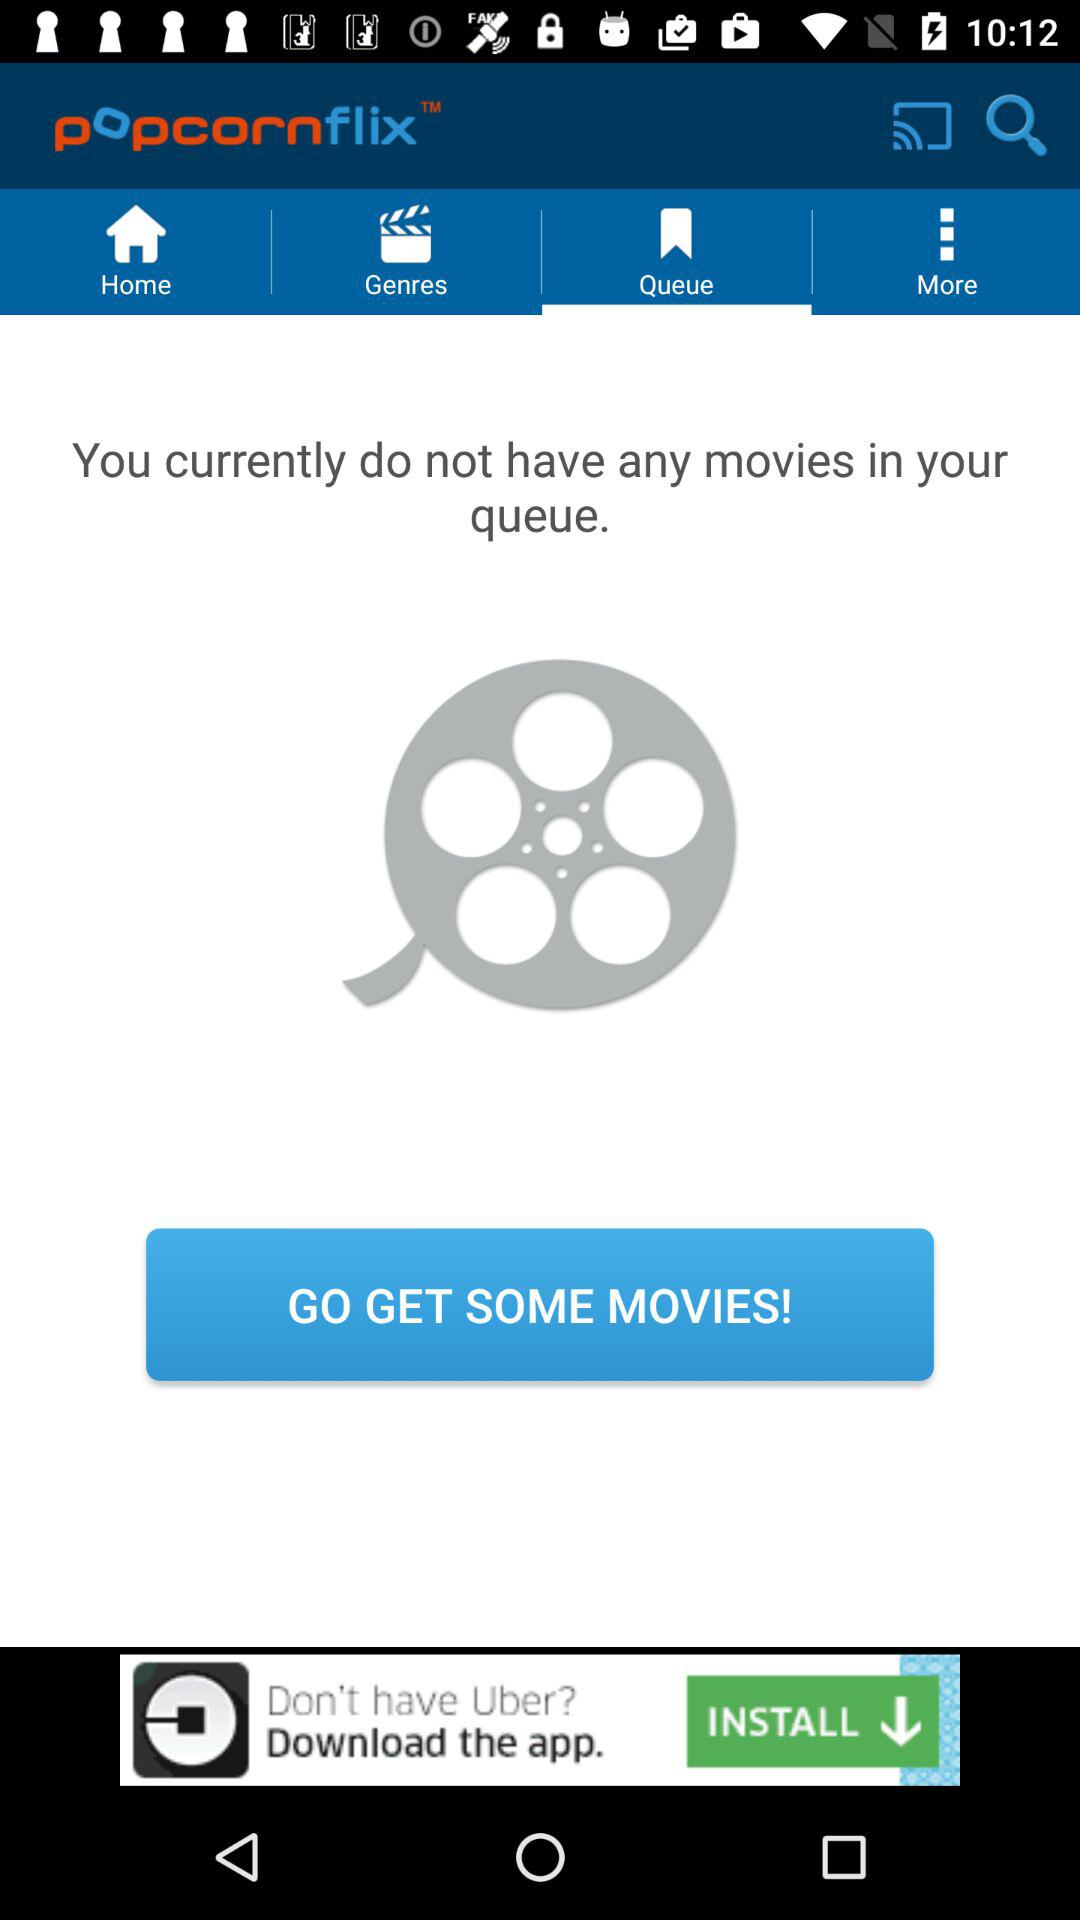How many movies are in the queue?
Answer the question using a single word or phrase. 0 